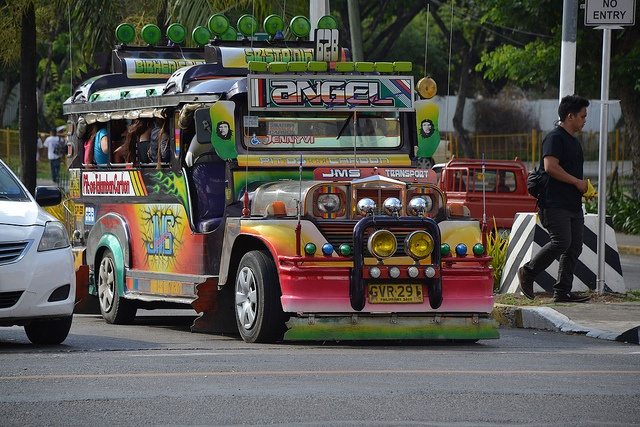Describe the objects in this image and their specific colors. I can see bus in black, gray, darkgray, and maroon tones, car in black, darkgray, gray, and white tones, people in black, maroon, gray, and darkgray tones, truck in black, maroon, gray, and brown tones, and people in black, darkgray, and gray tones in this image. 